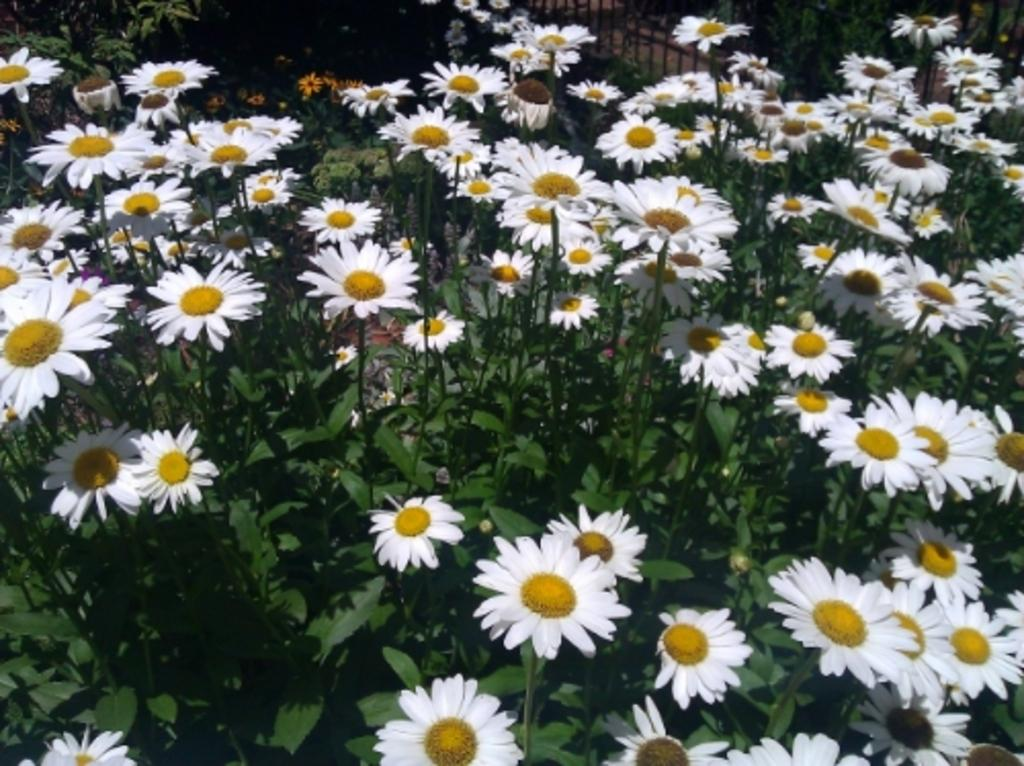What type of plants can be seen in the image? There are plants with flowers in the image. What can be seen in the background of the image? There is a fence in the background of the image. What year is the cabbage harvested in the image? There is no cabbage present in the image, and therefore no harvesting can be observed. 